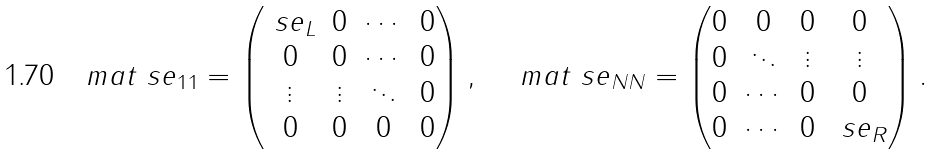<formula> <loc_0><loc_0><loc_500><loc_500>\ m a t { \ s e } _ { 1 1 } = \left ( \begin{matrix} \ s e _ { L } & 0 & \cdots & 0 \\ 0 & 0 & \cdots & 0 \\ \vdots & \vdots & \ddots & 0 \\ 0 & 0 & 0 & 0 \\ \end{matrix} \right ) , \quad \ m a t { \ s e } _ { N N } = \left ( \begin{matrix} 0 & 0 & 0 & 0 \\ 0 & \ddots & \vdots & \vdots \\ 0 & \cdots & 0 & 0 \\ 0 & \cdots & 0 & \ s e _ { R } \\ \end{matrix} \right ) .</formula> 